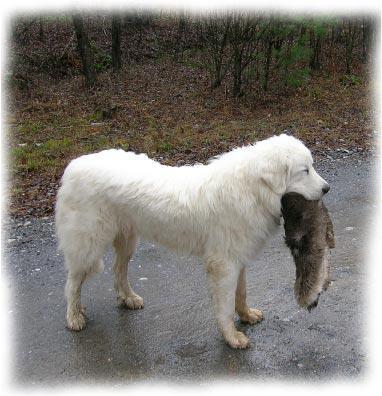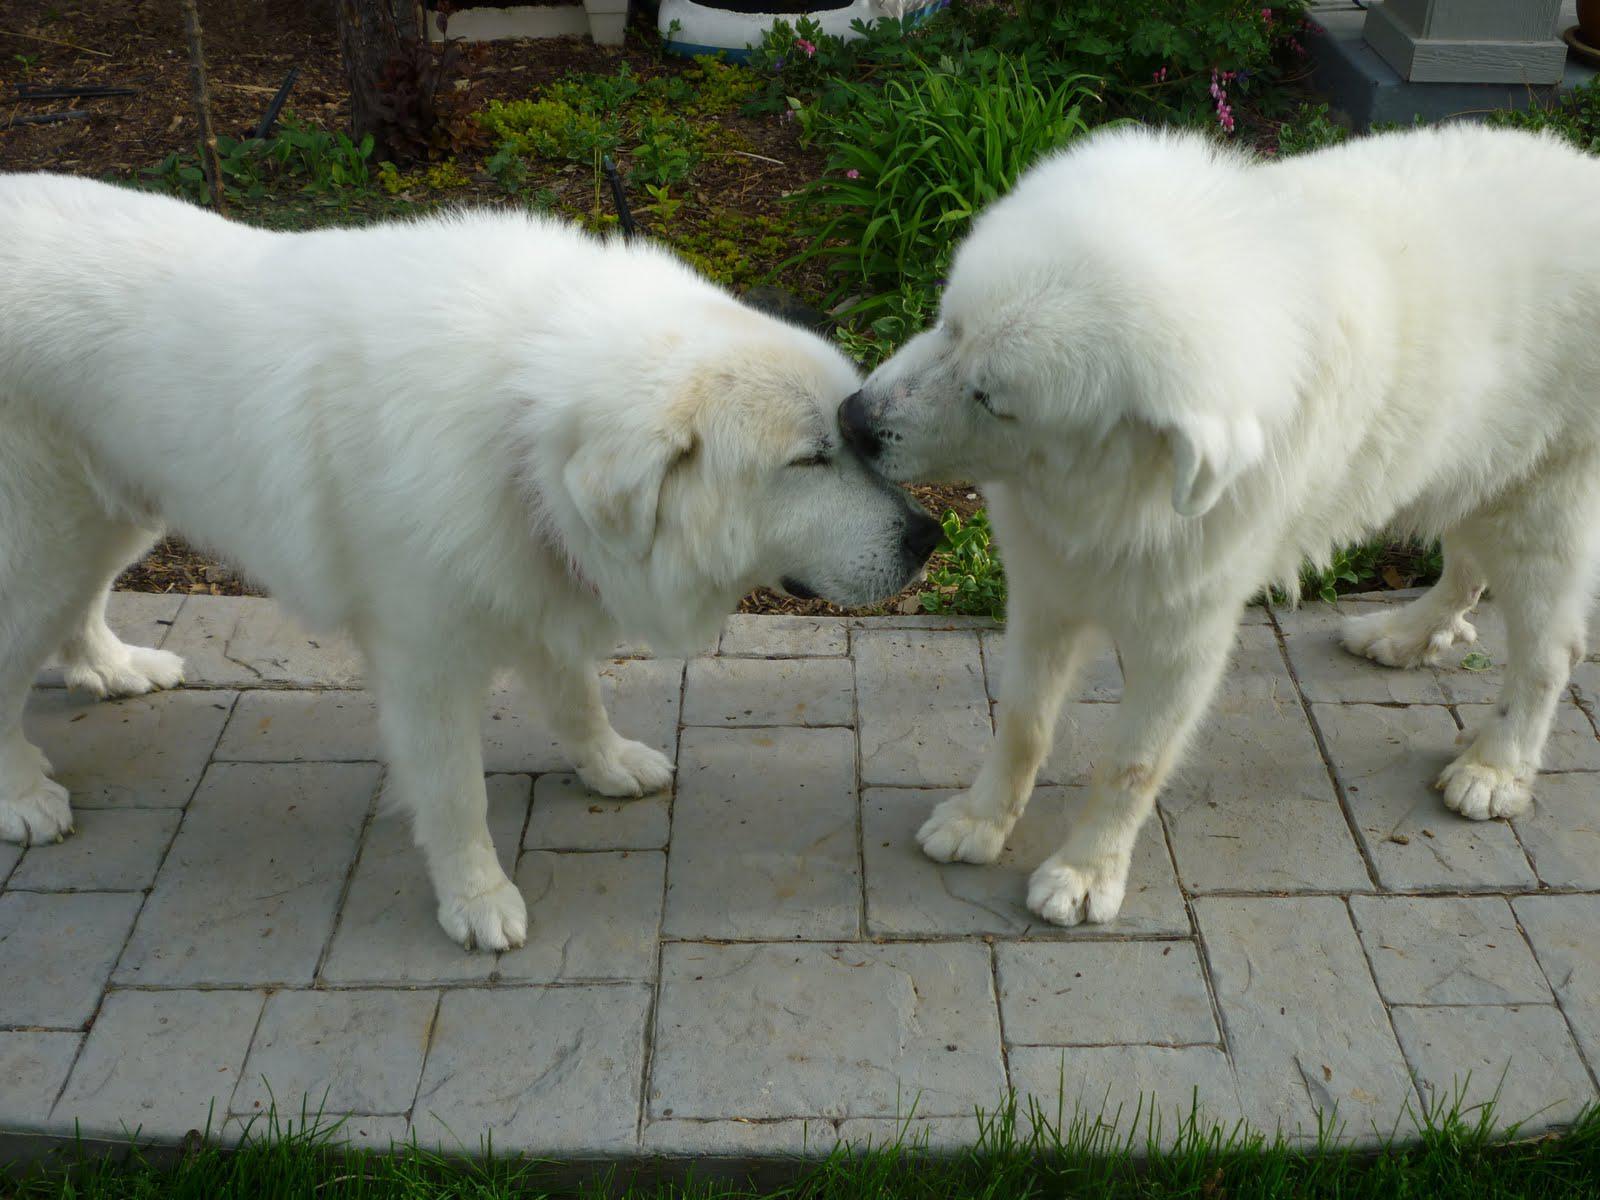The first image is the image on the left, the second image is the image on the right. Given the left and right images, does the statement "Two dogs are standing in the grass in one of the images." hold true? Answer yes or no. No. The first image is the image on the left, the second image is the image on the right. Analyze the images presented: Is the assertion "An image shows a standing dog with something furry in its mouth." valid? Answer yes or no. Yes. 